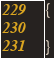<code> <loc_0><loc_0><loc_500><loc_500><_C++_>{

}
</code> 